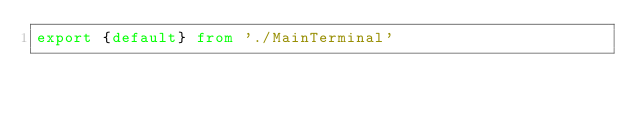Convert code to text. <code><loc_0><loc_0><loc_500><loc_500><_TypeScript_>export {default} from './MainTerminal'</code> 